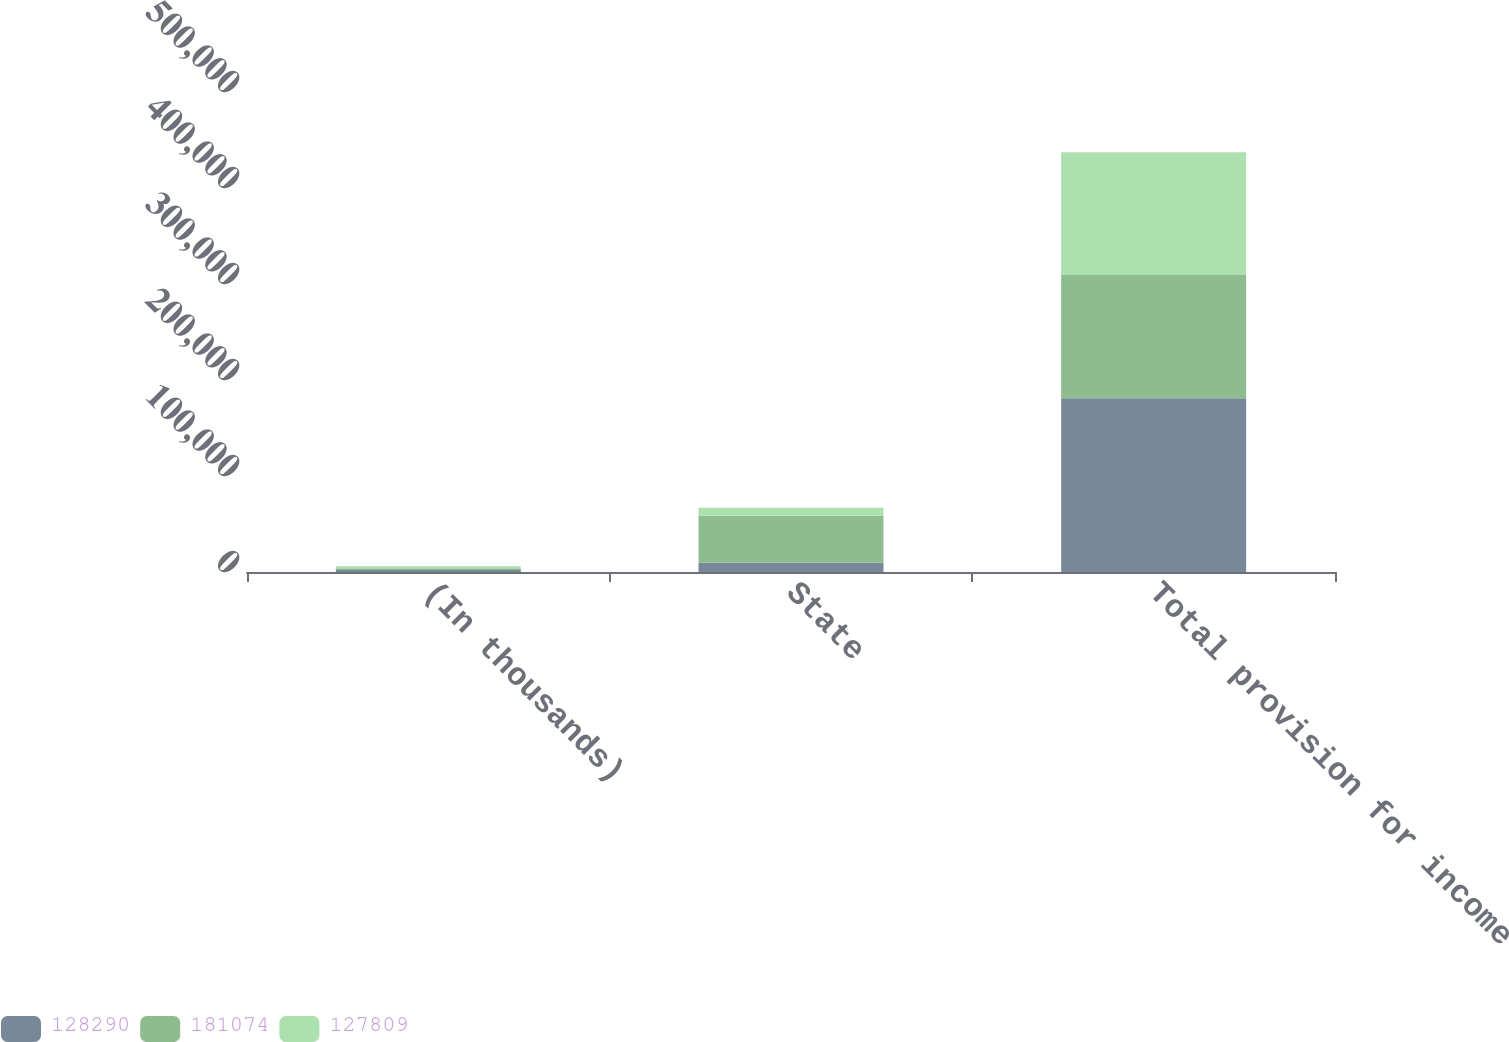Convert chart. <chart><loc_0><loc_0><loc_500><loc_500><stacked_bar_chart><ecel><fcel>(In thousands)<fcel>State<fcel>Total provision for income<nl><fcel>128290<fcel>2005<fcel>9596<fcel>181074<nl><fcel>181074<fcel>2004<fcel>48875<fcel>128290<nl><fcel>127809<fcel>2003<fcel>8485<fcel>127809<nl></chart> 